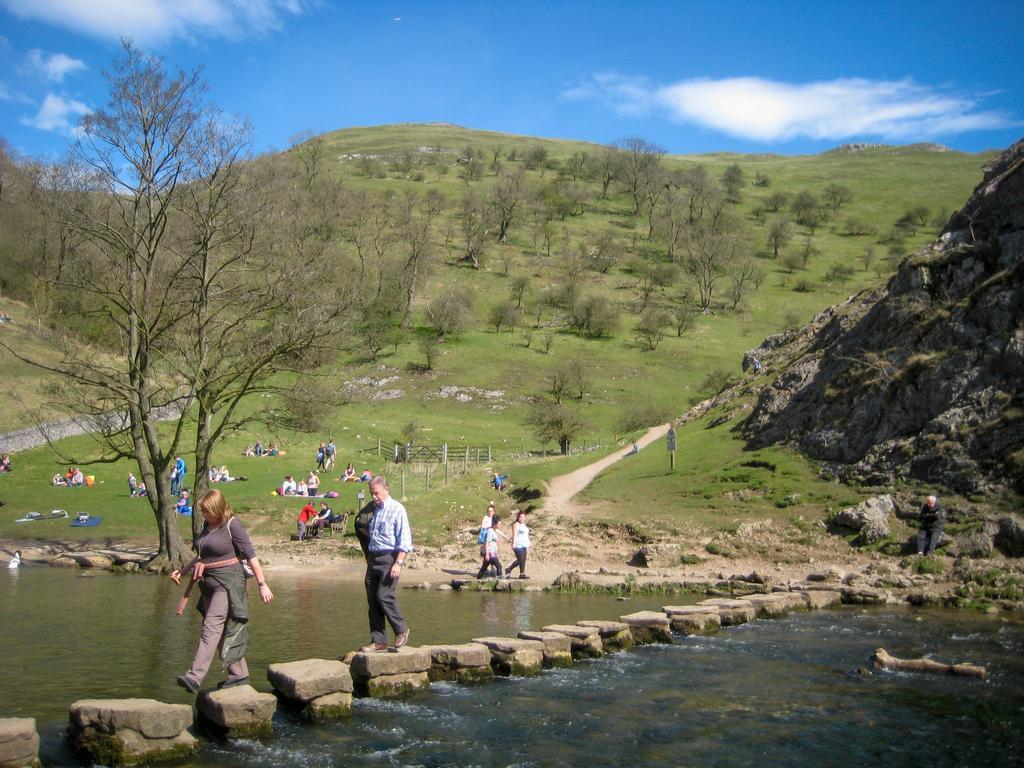Describe this image in one or two sentences. In this image in the center there are two persons, who are walking on rocks and at the bottom there is lake. In the background there are group of people sitting and some of them are walking, and there is a fence grass and some trees. On the right side there is a mountain and in the background there are mountains, at the top there is sky. 